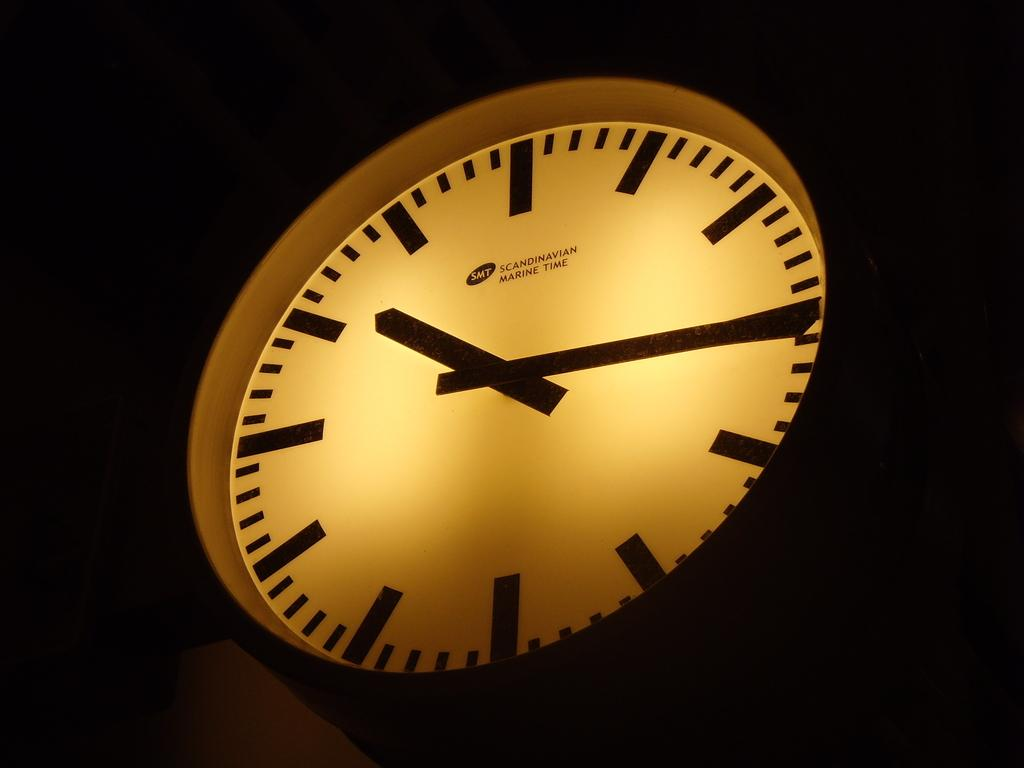What object in the image provides information about time? There is a clock in the image. What feature of the clock is mentioned in the facts? There is light in the clock. How would you describe the lighting conditions around the clock in the image? The area around the clock is dark. What type of spark can be seen coming from the chickens in the image? There are no chickens present in the image, so there cannot be any sparks coming from them. 